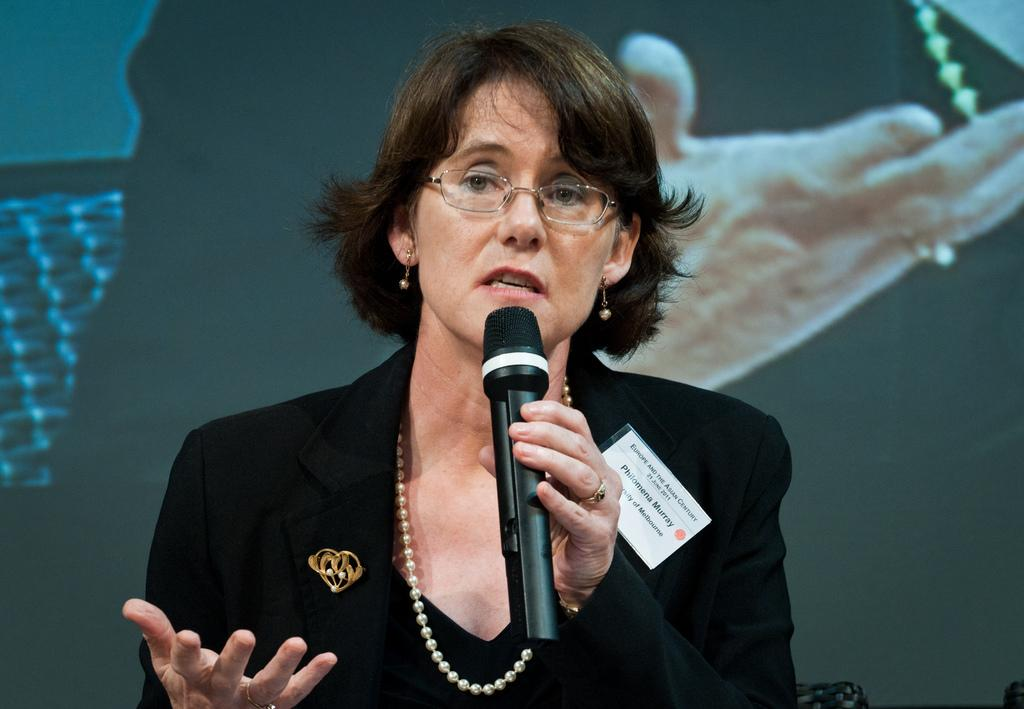What is the woman in the image doing? The woman is speaking into a microphone. What is the woman wearing in the image? The woman is wearing a black coat. What type of iron can be seen in the woman's hand in the image? There is no iron present in the image; the woman is holding a microphone. What type of slip is the woman wearing on her feet in the image? There is no information about the woman's footwear in the image. 